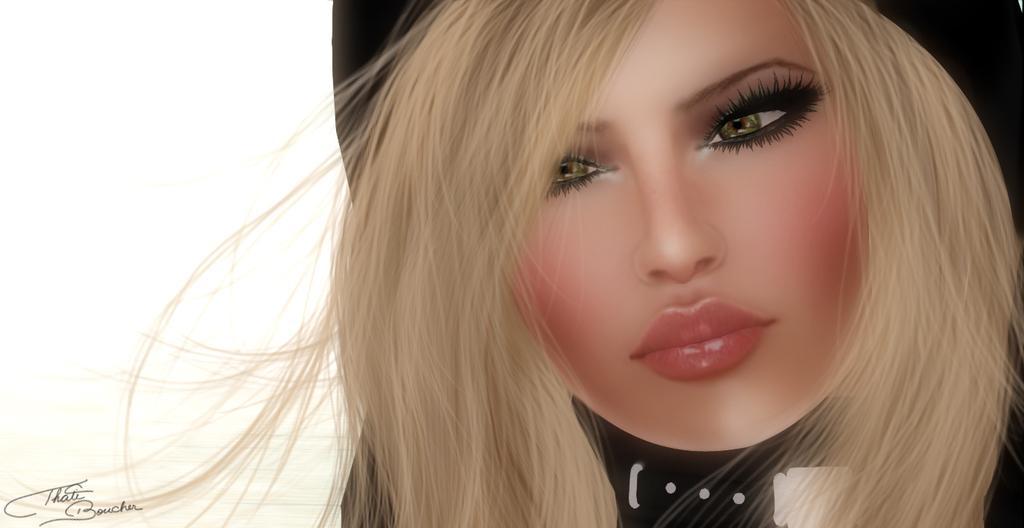Describe this image in one or two sentences. As we can see in the image there is animation of a woman wearing black color dress. 